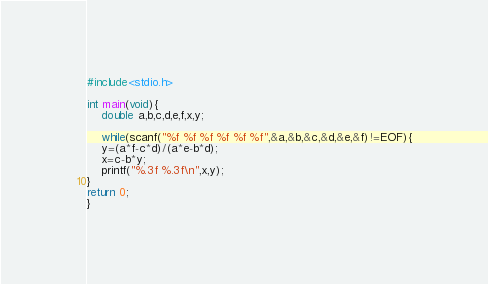Convert code to text. <code><loc_0><loc_0><loc_500><loc_500><_C_>#include<stdio.h>

int main(void){
	double a,b,c,d,e,f,x,y;

	while(scanf("%f %f %f %f %f %f",&a,&b,&c,&d,&e,&f)!=EOF){
	y=(a*f-c*d)/(a*e-b*d);
	x=c-b*y;
	printf("%.3f %.3f\n",x,y);
}
return 0;
}</code> 